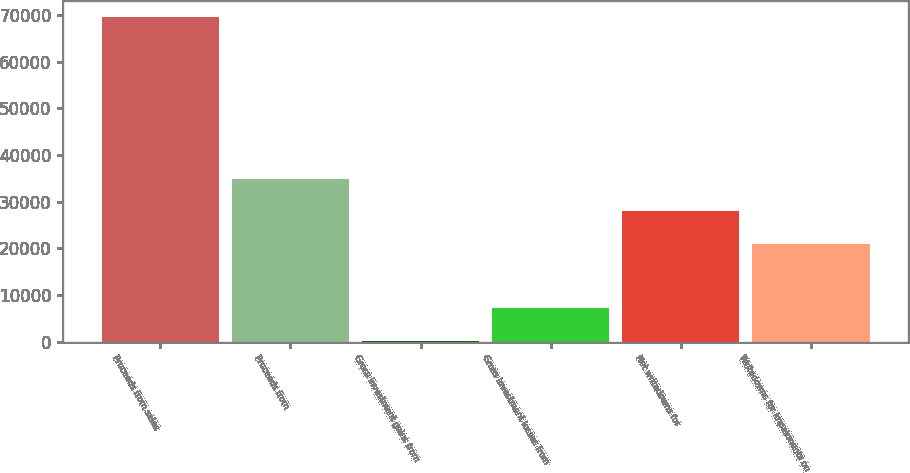Convert chart. <chart><loc_0><loc_0><loc_500><loc_500><bar_chart><fcel>Proceeds from sales<fcel>Proceeds from<fcel>Gross investment gains from<fcel>Gross investment losses from<fcel>Net writedowns for<fcel>Writedowns for impairments on<nl><fcel>69536<fcel>34890.5<fcel>245<fcel>7174.1<fcel>27961.4<fcel>21032.3<nl></chart> 